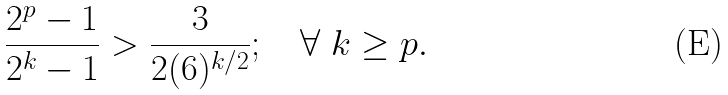<formula> <loc_0><loc_0><loc_500><loc_500>\frac { 2 ^ { p } - 1 } { 2 ^ { k } - 1 } > \frac { 3 } { 2 ( 6 ) ^ { k / 2 } } ; \quad \forall \ k \geq p .</formula> 